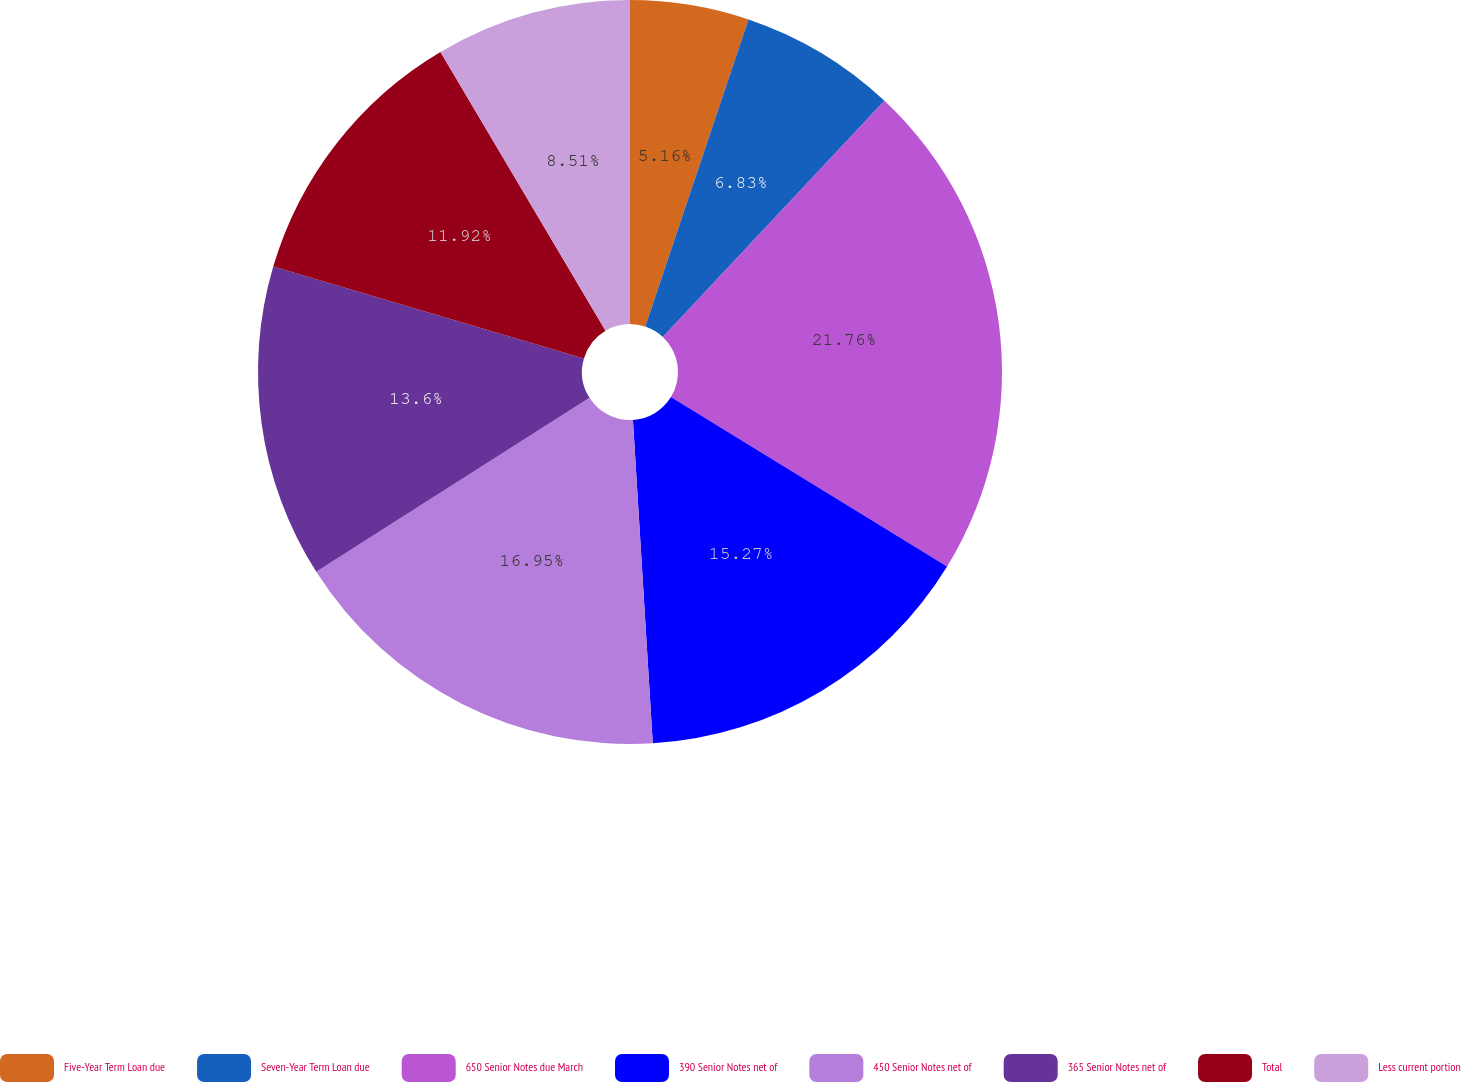Convert chart. <chart><loc_0><loc_0><loc_500><loc_500><pie_chart><fcel>Five-Year Term Loan due<fcel>Seven-Year Term Loan due<fcel>650 Senior Notes due March<fcel>390 Senior Notes net of<fcel>450 Senior Notes net of<fcel>365 Senior Notes net of<fcel>Total<fcel>Less current portion<nl><fcel>5.16%<fcel>6.83%<fcel>21.77%<fcel>15.27%<fcel>16.95%<fcel>13.6%<fcel>11.92%<fcel>8.51%<nl></chart> 